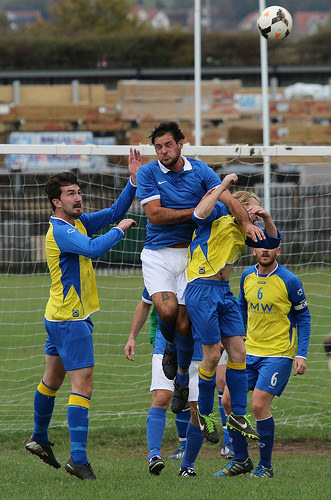<image>
Is the man on the grass? No. The man is not positioned on the grass. They may be near each other, but the man is not supported by or resting on top of the grass. Is the pole behind the ball? Yes. From this viewpoint, the pole is positioned behind the ball, with the ball partially or fully occluding the pole. 